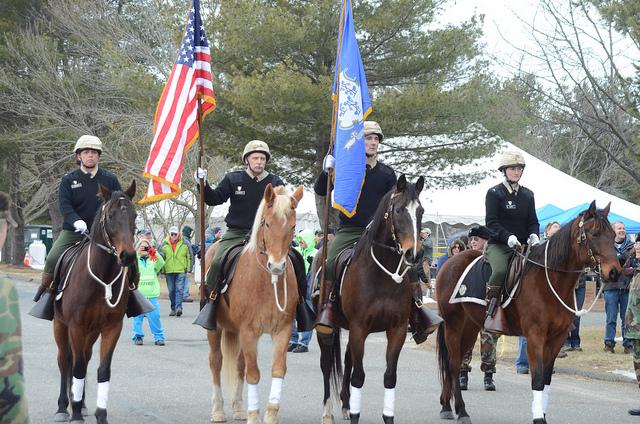What is the officer carrying in his right hand?
Answer briefly. Flag. What nations flag is the man on the left holding?
Write a very short answer. Usa. What is the woman in the light green jacket behind the horses doing?
Give a very brief answer. Taking picture. 